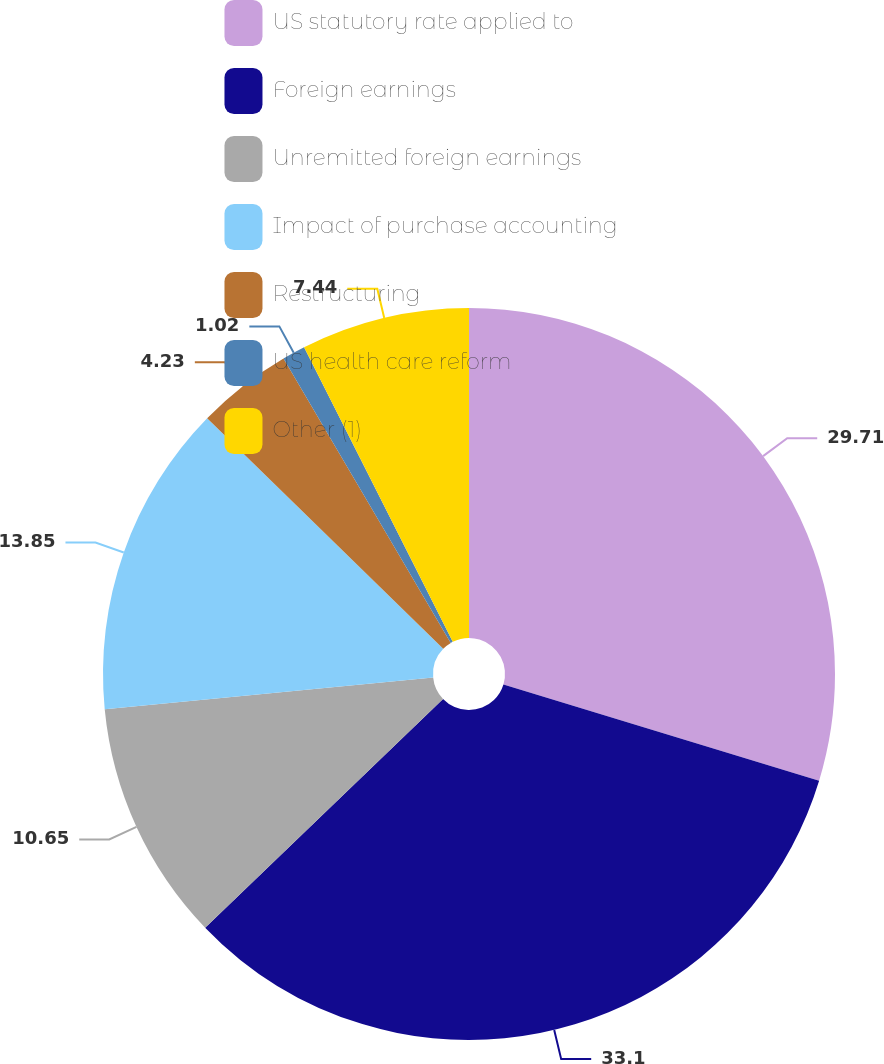Convert chart. <chart><loc_0><loc_0><loc_500><loc_500><pie_chart><fcel>US statutory rate applied to<fcel>Foreign earnings<fcel>Unremitted foreign earnings<fcel>Impact of purchase accounting<fcel>Restructuring<fcel>US health care reform<fcel>Other (1)<nl><fcel>29.71%<fcel>33.11%<fcel>10.65%<fcel>13.85%<fcel>4.23%<fcel>1.02%<fcel>7.44%<nl></chart> 